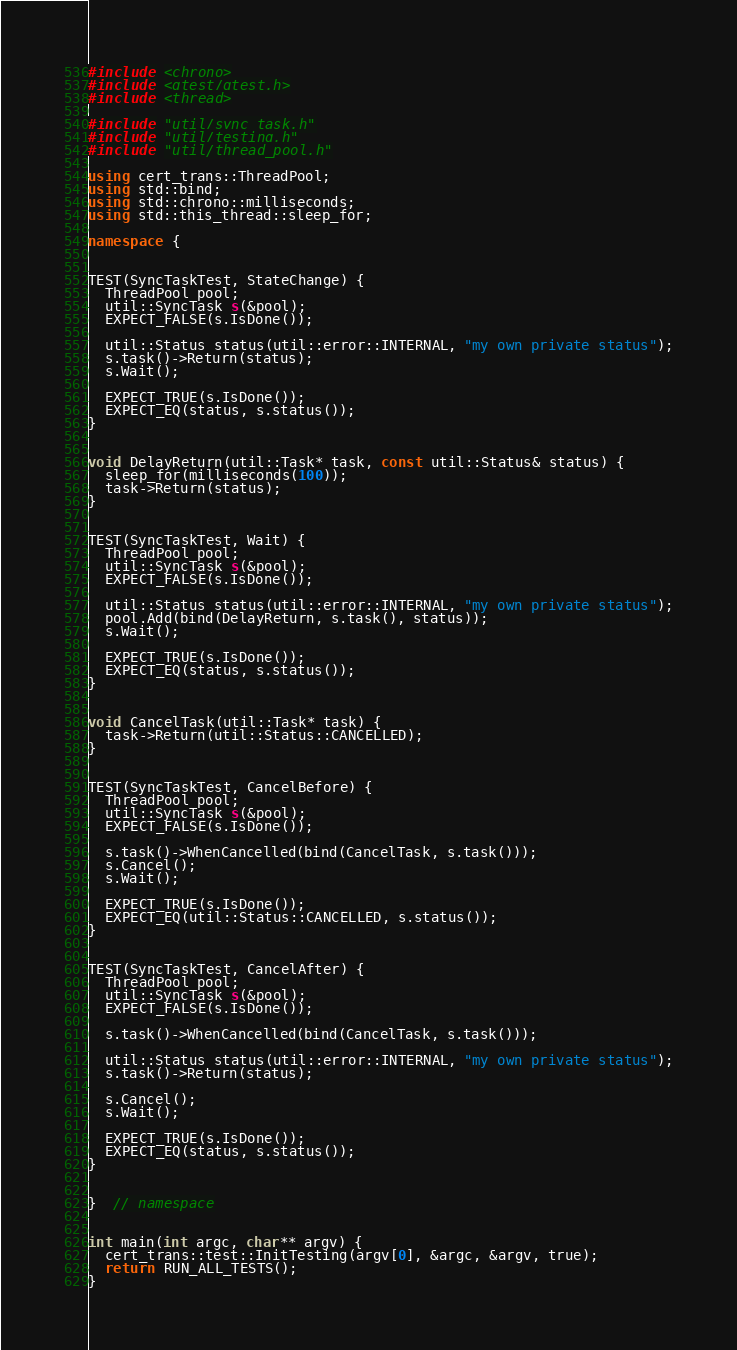Convert code to text. <code><loc_0><loc_0><loc_500><loc_500><_C++_>#include <chrono>
#include <gtest/gtest.h>
#include <thread>

#include "util/sync_task.h"
#include "util/testing.h"
#include "util/thread_pool.h"

using cert_trans::ThreadPool;
using std::bind;
using std::chrono::milliseconds;
using std::this_thread::sleep_for;

namespace {


TEST(SyncTaskTest, StateChange) {
  ThreadPool pool;
  util::SyncTask s(&pool);
  EXPECT_FALSE(s.IsDone());

  util::Status status(util::error::INTERNAL, "my own private status");
  s.task()->Return(status);
  s.Wait();

  EXPECT_TRUE(s.IsDone());
  EXPECT_EQ(status, s.status());
}


void DelayReturn(util::Task* task, const util::Status& status) {
  sleep_for(milliseconds(100));
  task->Return(status);
}


TEST(SyncTaskTest, Wait) {
  ThreadPool pool;
  util::SyncTask s(&pool);
  EXPECT_FALSE(s.IsDone());

  util::Status status(util::error::INTERNAL, "my own private status");
  pool.Add(bind(DelayReturn, s.task(), status));
  s.Wait();

  EXPECT_TRUE(s.IsDone());
  EXPECT_EQ(status, s.status());
}


void CancelTask(util::Task* task) {
  task->Return(util::Status::CANCELLED);
}


TEST(SyncTaskTest, CancelBefore) {
  ThreadPool pool;
  util::SyncTask s(&pool);
  EXPECT_FALSE(s.IsDone());

  s.task()->WhenCancelled(bind(CancelTask, s.task()));
  s.Cancel();
  s.Wait();

  EXPECT_TRUE(s.IsDone());
  EXPECT_EQ(util::Status::CANCELLED, s.status());
}


TEST(SyncTaskTest, CancelAfter) {
  ThreadPool pool;
  util::SyncTask s(&pool);
  EXPECT_FALSE(s.IsDone());

  s.task()->WhenCancelled(bind(CancelTask, s.task()));

  util::Status status(util::error::INTERNAL, "my own private status");
  s.task()->Return(status);

  s.Cancel();
  s.Wait();

  EXPECT_TRUE(s.IsDone());
  EXPECT_EQ(status, s.status());
}


}  // namespace


int main(int argc, char** argv) {
  cert_trans::test::InitTesting(argv[0], &argc, &argv, true);
  return RUN_ALL_TESTS();
}
</code> 